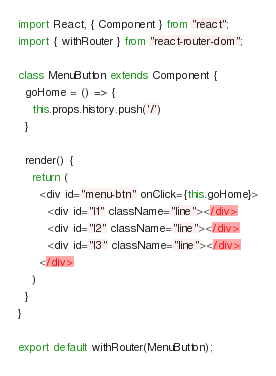Convert code to text. <code><loc_0><loc_0><loc_500><loc_500><_JavaScript_>import React, { Component } from "react";
import { withRouter } from "react-router-dom";

class MenuButton extends Component {
  goHome = () => {
    this.props.history.push('/')
  }

  render() {
    return (
      <div id="menu-btn" onClick={this.goHome}>
        <div id="l1" className="line"></div>
        <div id="l2" className="line"></div>
        <div id="l3" className="line"></div>
      </div>
    )
  }
}

export default withRouter(MenuButton);</code> 